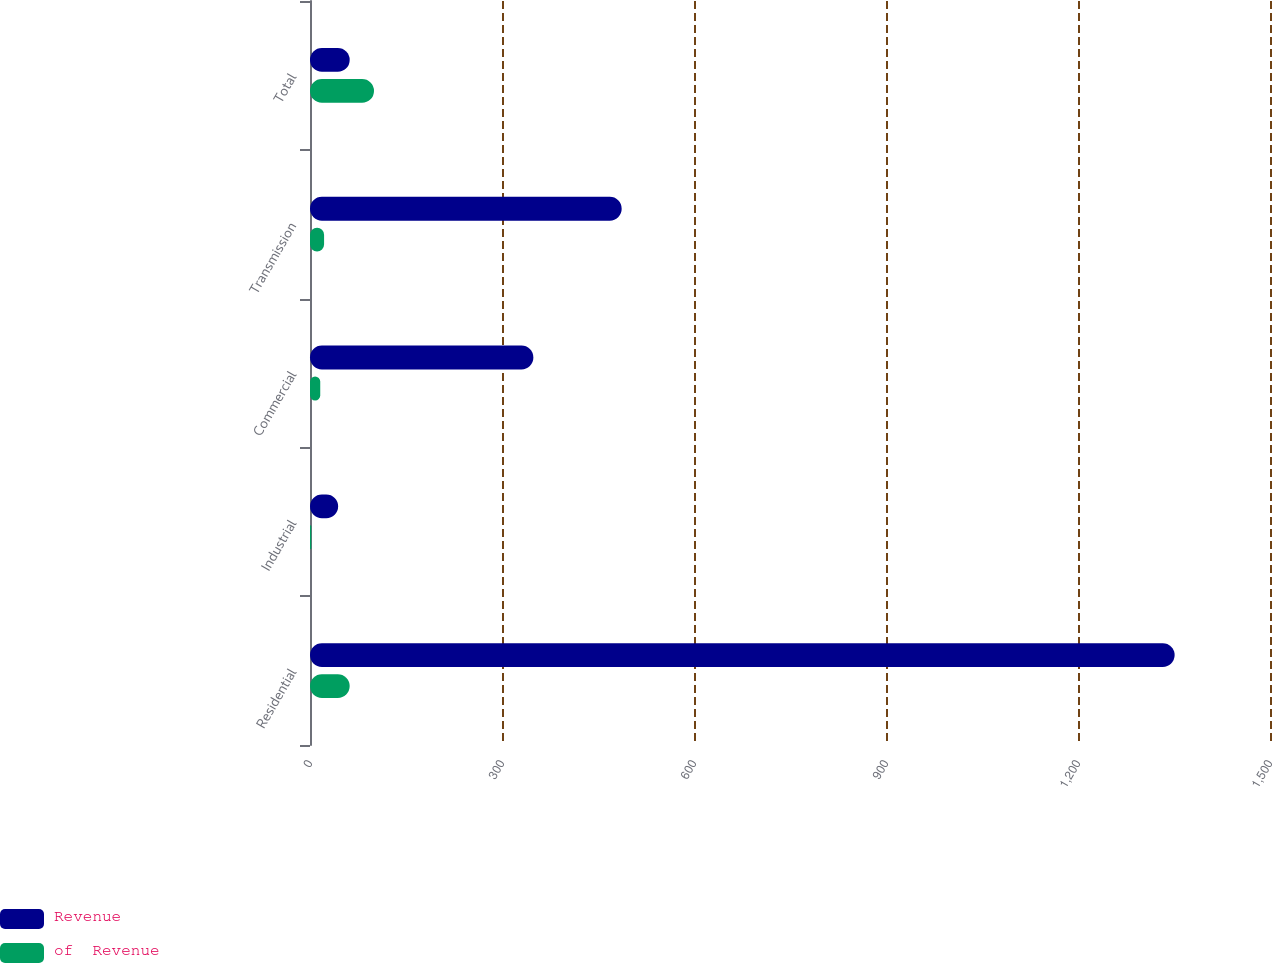Convert chart to OTSL. <chart><loc_0><loc_0><loc_500><loc_500><stacked_bar_chart><ecel><fcel>Residential<fcel>Industrial<fcel>Commercial<fcel>Transmission<fcel>Total<nl><fcel>Revenue<fcel>1351<fcel>44<fcel>349<fcel>487<fcel>62<nl><fcel>of  Revenue<fcel>62<fcel>2<fcel>16<fcel>22<fcel>100<nl></chart> 